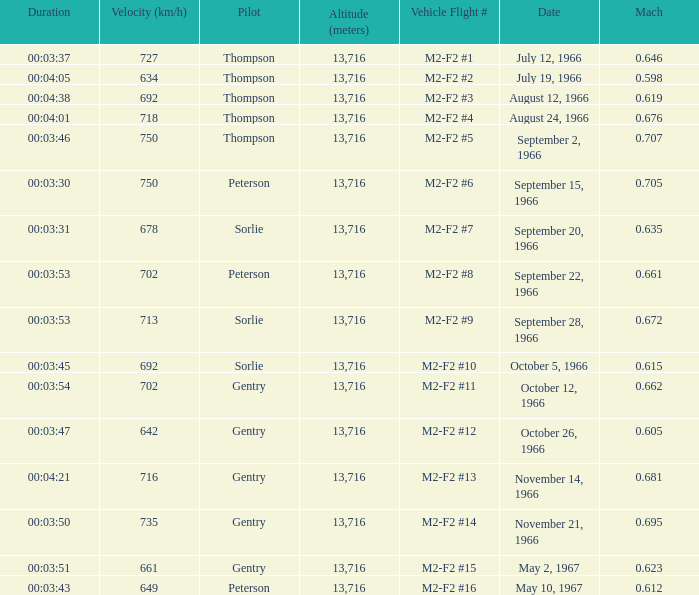What Date has a Mach of 0.662? October 12, 1966. 